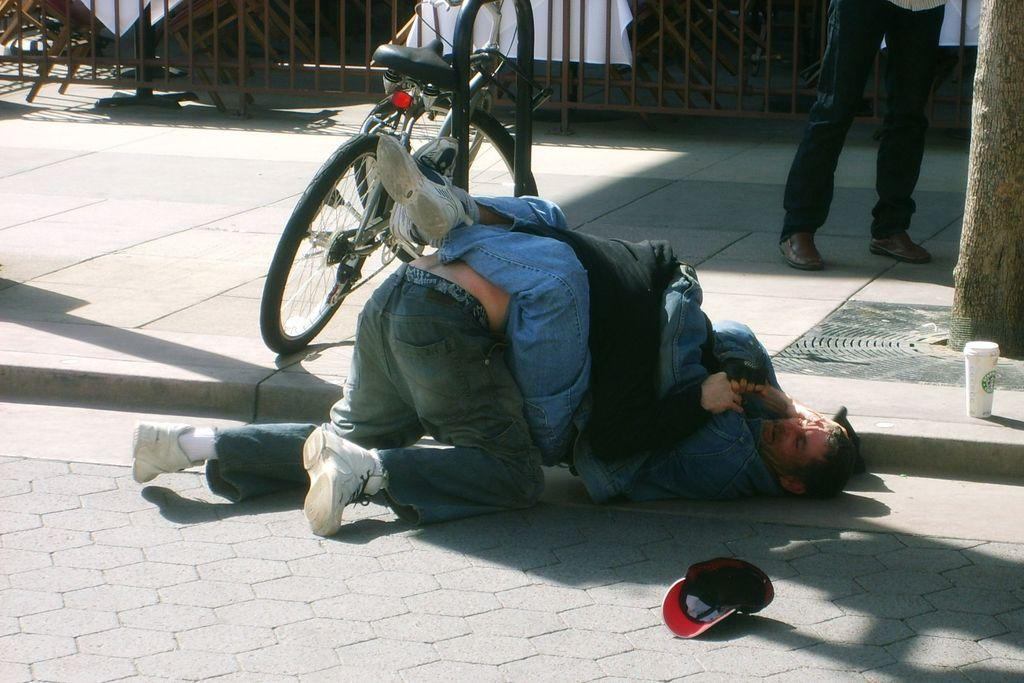How many people are in the image? There are two persons in the image. What are the two persons doing in the image? The two persons appear to be fighting. Where does the scene take place? The scene takes place on a road. What can be seen near one of the persons? There is a small bottle near one of the persons. What type of object is present in the image that is commonly used for transportation? There is a bicycle in the image. What part of a person's body is visible in the image? A person's legs are visible in the image. What type of barrier can be seen in the image? There is a fence in the image. What type of headwear is present in the image? There is a cap in the image. What type of nail can be seen being hammered into the fence in the image? There is no nail being hammered into the fence in the image. What type of game are the two persons playing in the image? The two persons are not playing a game; they appear to be fighting. 